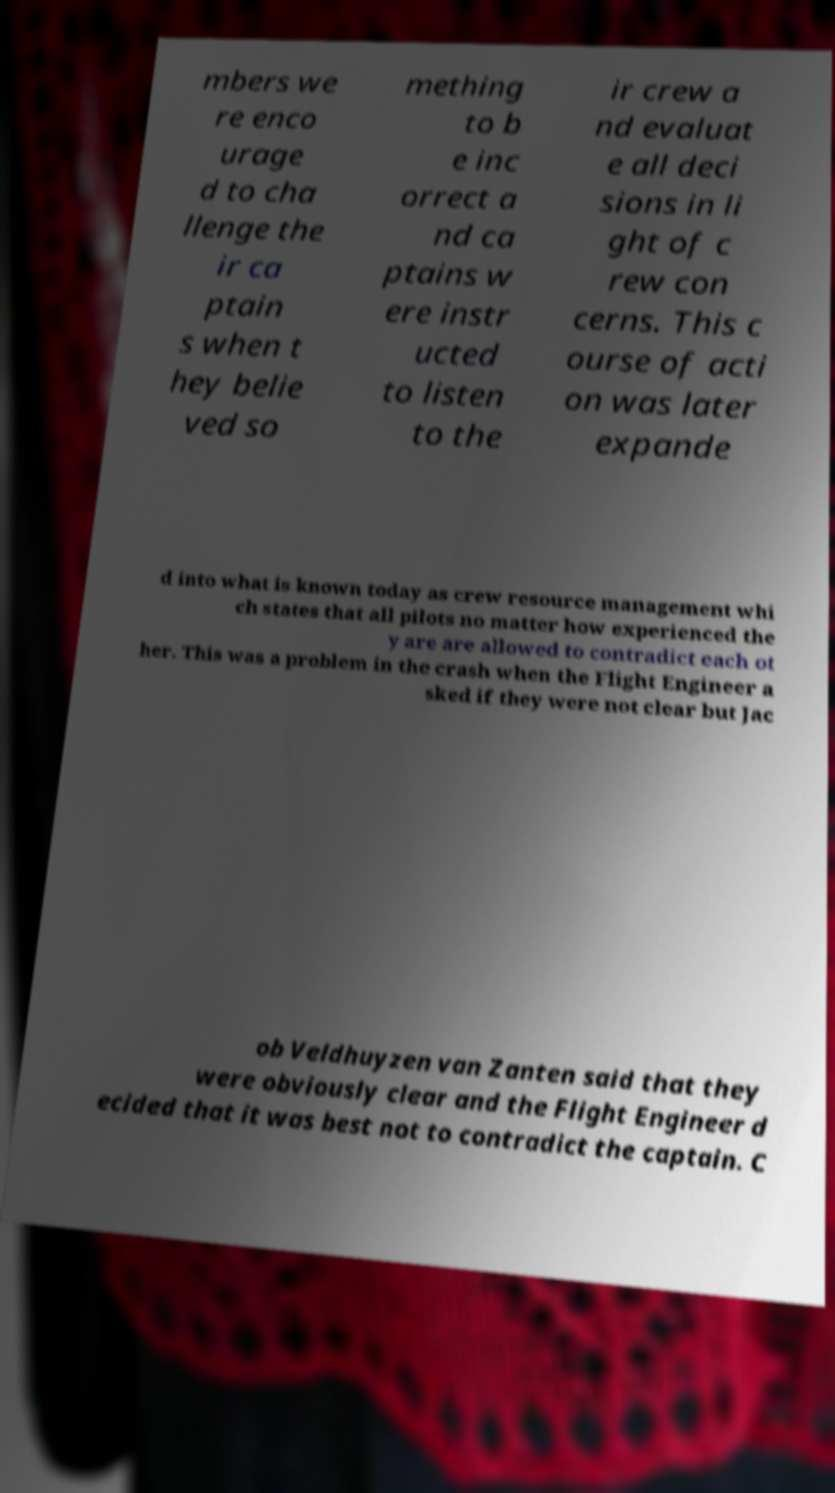Please identify and transcribe the text found in this image. mbers we re enco urage d to cha llenge the ir ca ptain s when t hey belie ved so mething to b e inc orrect a nd ca ptains w ere instr ucted to listen to the ir crew a nd evaluat e all deci sions in li ght of c rew con cerns. This c ourse of acti on was later expande d into what is known today as crew resource management whi ch states that all pilots no matter how experienced the y are are allowed to contradict each ot her. This was a problem in the crash when the Flight Engineer a sked if they were not clear but Jac ob Veldhuyzen van Zanten said that they were obviously clear and the Flight Engineer d ecided that it was best not to contradict the captain. C 